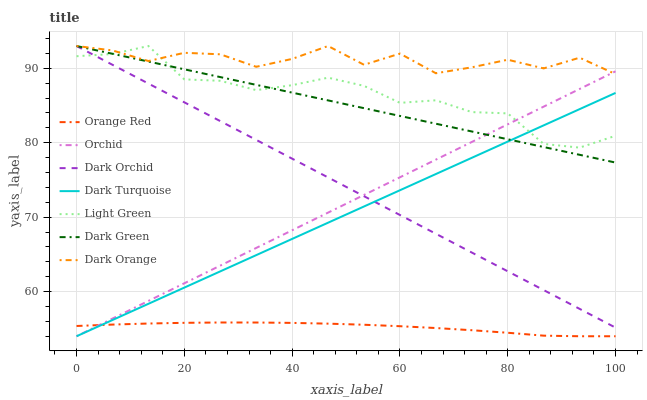Does Orange Red have the minimum area under the curve?
Answer yes or no. Yes. Does Dark Orange have the maximum area under the curve?
Answer yes or no. Yes. Does Dark Turquoise have the minimum area under the curve?
Answer yes or no. No. Does Dark Turquoise have the maximum area under the curve?
Answer yes or no. No. Is Dark Turquoise the smoothest?
Answer yes or no. Yes. Is Dark Orange the roughest?
Answer yes or no. Yes. Is Dark Orchid the smoothest?
Answer yes or no. No. Is Dark Orchid the roughest?
Answer yes or no. No. Does Dark Turquoise have the lowest value?
Answer yes or no. Yes. Does Dark Orchid have the lowest value?
Answer yes or no. No. Does Dark Green have the highest value?
Answer yes or no. Yes. Does Dark Turquoise have the highest value?
Answer yes or no. No. Is Orange Red less than Dark Orchid?
Answer yes or no. Yes. Is Dark Green greater than Orange Red?
Answer yes or no. Yes. Does Dark Orange intersect Dark Orchid?
Answer yes or no. Yes. Is Dark Orange less than Dark Orchid?
Answer yes or no. No. Is Dark Orange greater than Dark Orchid?
Answer yes or no. No. Does Orange Red intersect Dark Orchid?
Answer yes or no. No. 